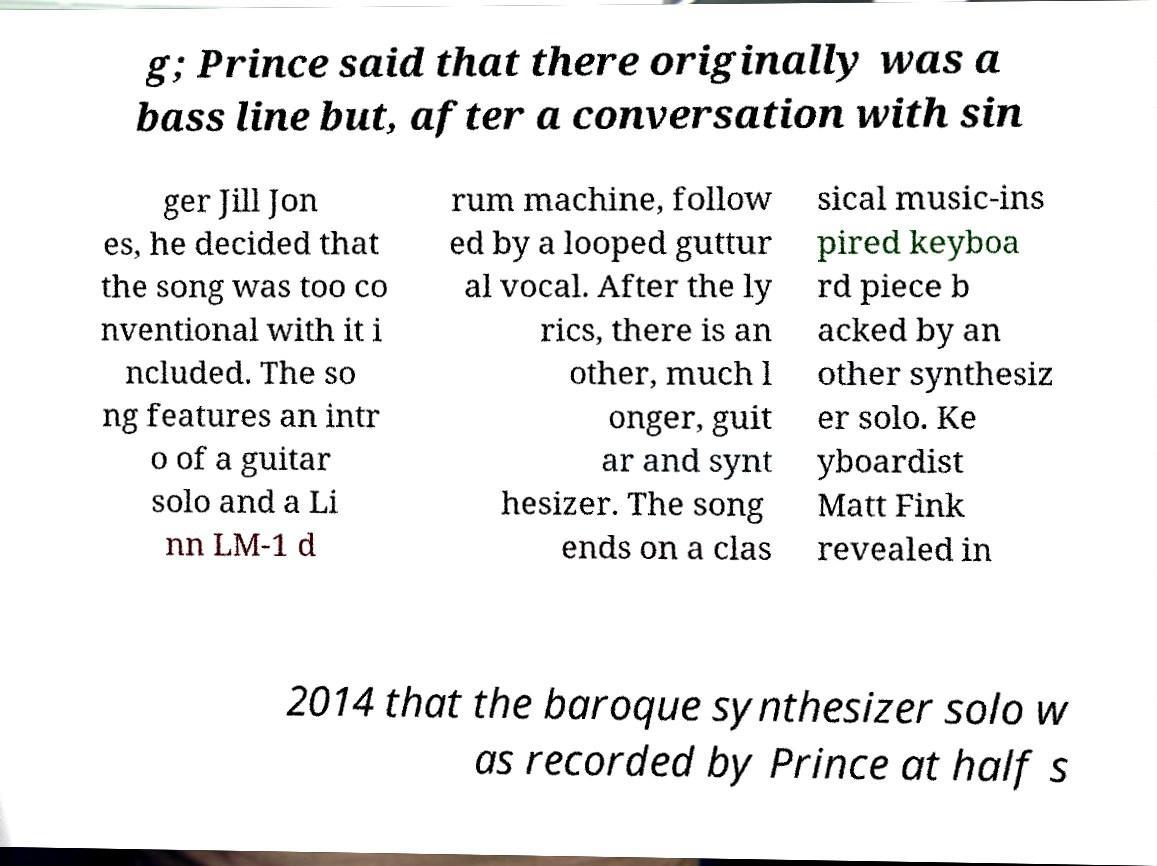Can you read and provide the text displayed in the image?This photo seems to have some interesting text. Can you extract and type it out for me? g; Prince said that there originally was a bass line but, after a conversation with sin ger Jill Jon es, he decided that the song was too co nventional with it i ncluded. The so ng features an intr o of a guitar solo and a Li nn LM-1 d rum machine, follow ed by a looped guttur al vocal. After the ly rics, there is an other, much l onger, guit ar and synt hesizer. The song ends on a clas sical music-ins pired keyboa rd piece b acked by an other synthesiz er solo. Ke yboardist Matt Fink revealed in 2014 that the baroque synthesizer solo w as recorded by Prince at half s 